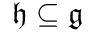Convert formula to latex. <formula><loc_0><loc_0><loc_500><loc_500>{ \mathfrak { h } } \subseteq { \mathfrak { g } }</formula> 